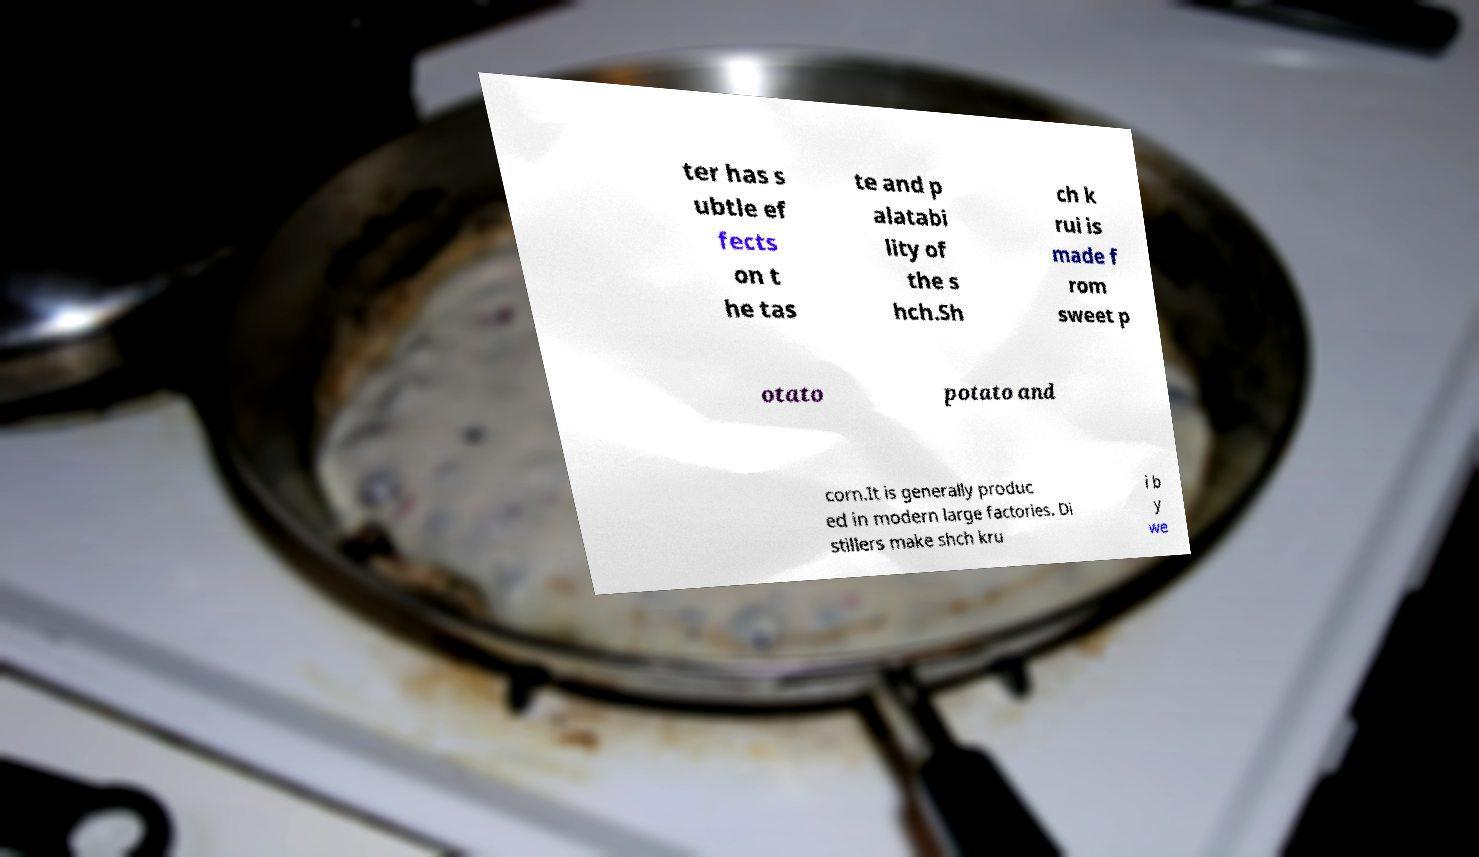Can you read and provide the text displayed in the image?This photo seems to have some interesting text. Can you extract and type it out for me? ter has s ubtle ef fects on t he tas te and p alatabi lity of the s hch.Sh ch k rui is made f rom sweet p otato potato and corn.It is generally produc ed in modern large factories. Di stillers make shch kru i b y we 